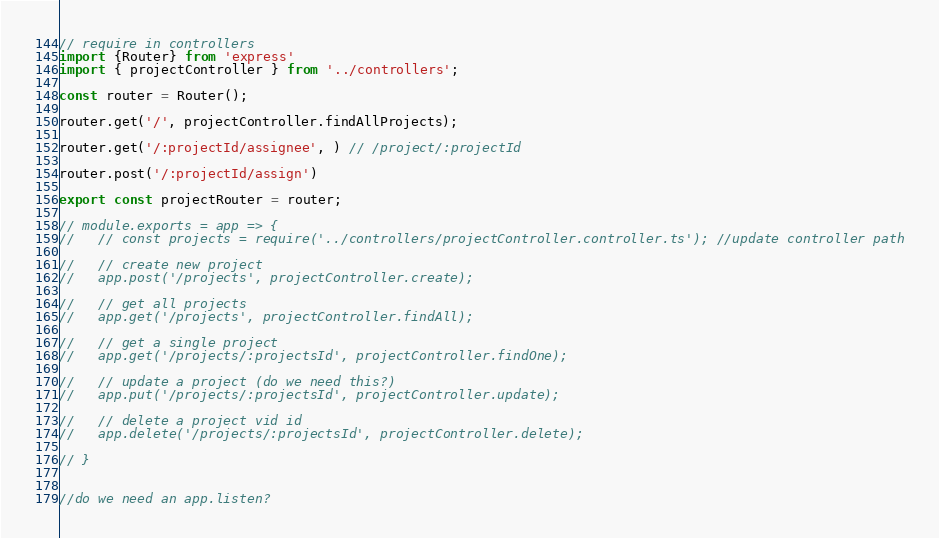Convert code to text. <code><loc_0><loc_0><loc_500><loc_500><_TypeScript_>// require in controllers
import {Router} from 'express'
import { projectController } from '../controllers';

const router = Router();

router.get('/', projectController.findAllProjects);

router.get('/:projectId/assignee', ) // /project/:projectId

router.post('/:projectId/assign')

export const projectRouter = router;

// module.exports = app => {
//   // const projects = require('../controllers/projectController.controller.ts'); //update controller path

//   // create new project
//   app.post('/projects', projectController.create);

//   // get all projects
//   app.get('/projects', projectController.findAll);

//   // get a single project
//   app.get('/projects/:projectsId', projectController.findOne);

//   // update a project (do we need this?)
//   app.put('/projects/:projectsId', projectController.update);

//   // delete a project vid id
//   app.delete('/projects/:projectsId', projectController.delete);

// }


//do we need an app.listen?</code> 